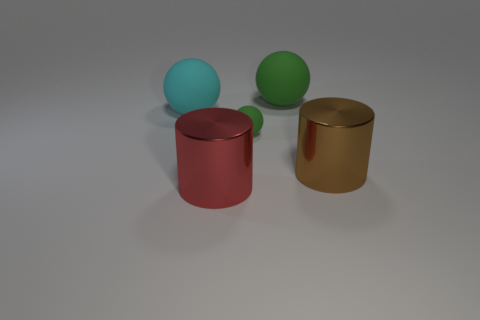How many other things are there of the same color as the small rubber object?
Provide a succinct answer. 1. How many other tiny rubber things have the same color as the small thing?
Provide a short and direct response. 0. What is the size of the object that is in front of the brown shiny cylinder?
Your answer should be compact. Large. How many green balls have the same size as the cyan thing?
Offer a very short reply. 1. The other big object that is the same material as the big brown thing is what color?
Make the answer very short. Red. Is the number of spheres right of the small ball less than the number of big things?
Keep it short and to the point. Yes. There is a red thing that is the same material as the brown object; what shape is it?
Ensure brevity in your answer.  Cylinder. What number of rubber objects are cyan objects or large brown cylinders?
Give a very brief answer. 1. Are there the same number of big cyan spheres that are in front of the small green object and red cylinders?
Offer a very short reply. No. There is a big matte sphere behind the big cyan rubber sphere; is its color the same as the tiny rubber ball?
Give a very brief answer. Yes. 